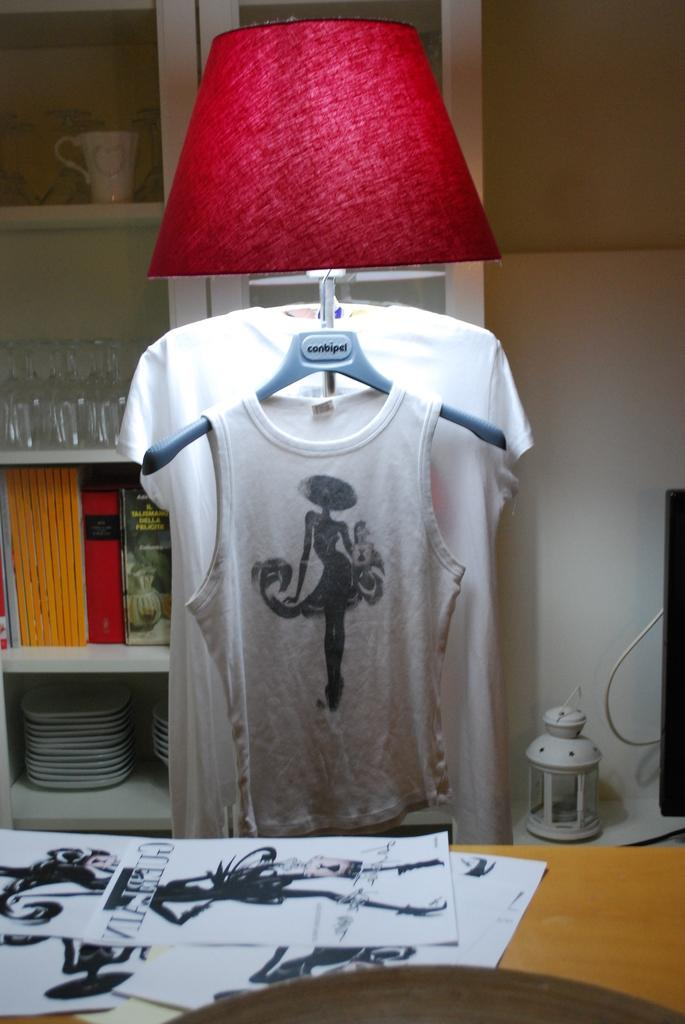What is on the table in the image? There are papers on the table in the image. What can be seen in the background of the image? A bed lamp and a T-shirt are visible in the background of the image, along with other unspecified objects. What type of bells can be heard ringing in the image? There are no bells present in the image, and therefore no sounds can be heard. 